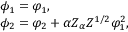<formula> <loc_0><loc_0><loc_500><loc_500>\begin{array} { l } { { \phi _ { 1 } = \varphi _ { 1 } , } } \\ { { \phi _ { 2 } = \varphi _ { 2 } + \alpha Z _ { \alpha } Z ^ { 1 / 2 } \varphi _ { 1 } ^ { 2 } , } } \end{array}</formula> 